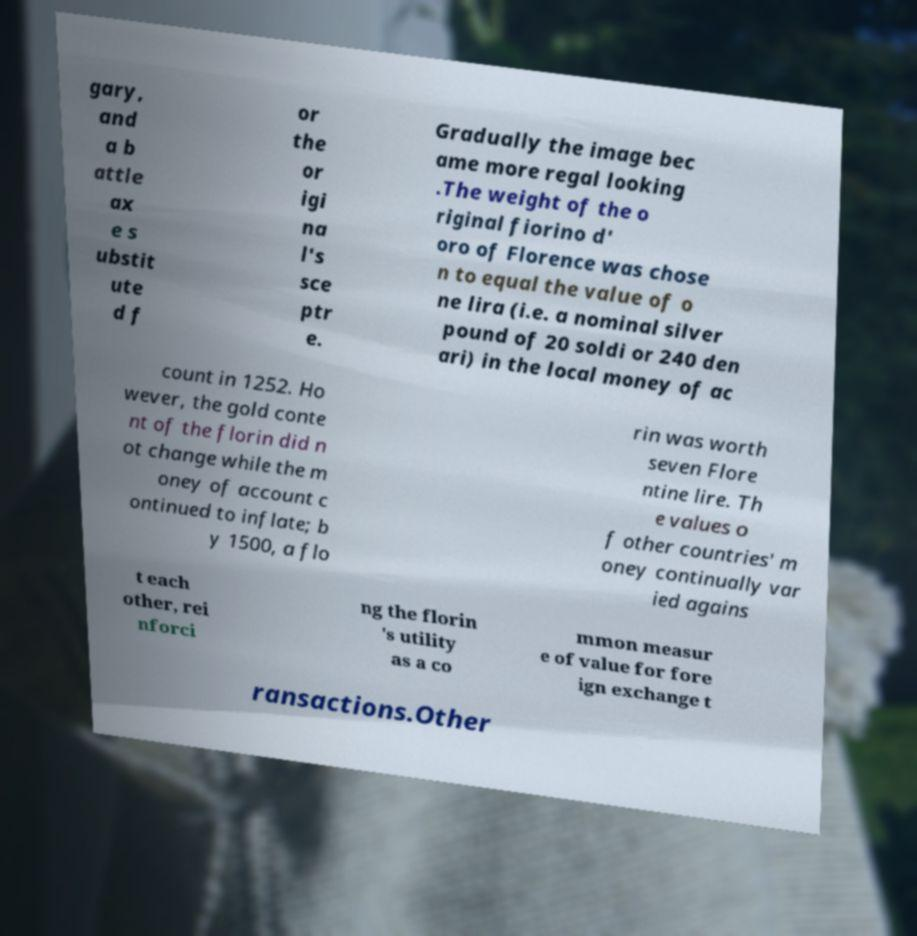Can you accurately transcribe the text from the provided image for me? gary, and a b attle ax e s ubstit ute d f or the or igi na l's sce ptr e. Gradually the image bec ame more regal looking .The weight of the o riginal fiorino d' oro of Florence was chose n to equal the value of o ne lira (i.e. a nominal silver pound of 20 soldi or 240 den ari) in the local money of ac count in 1252. Ho wever, the gold conte nt of the florin did n ot change while the m oney of account c ontinued to inflate; b y 1500, a flo rin was worth seven Flore ntine lire. Th e values o f other countries' m oney continually var ied agains t each other, rei nforci ng the florin 's utility as a co mmon measur e of value for fore ign exchange t ransactions.Other 